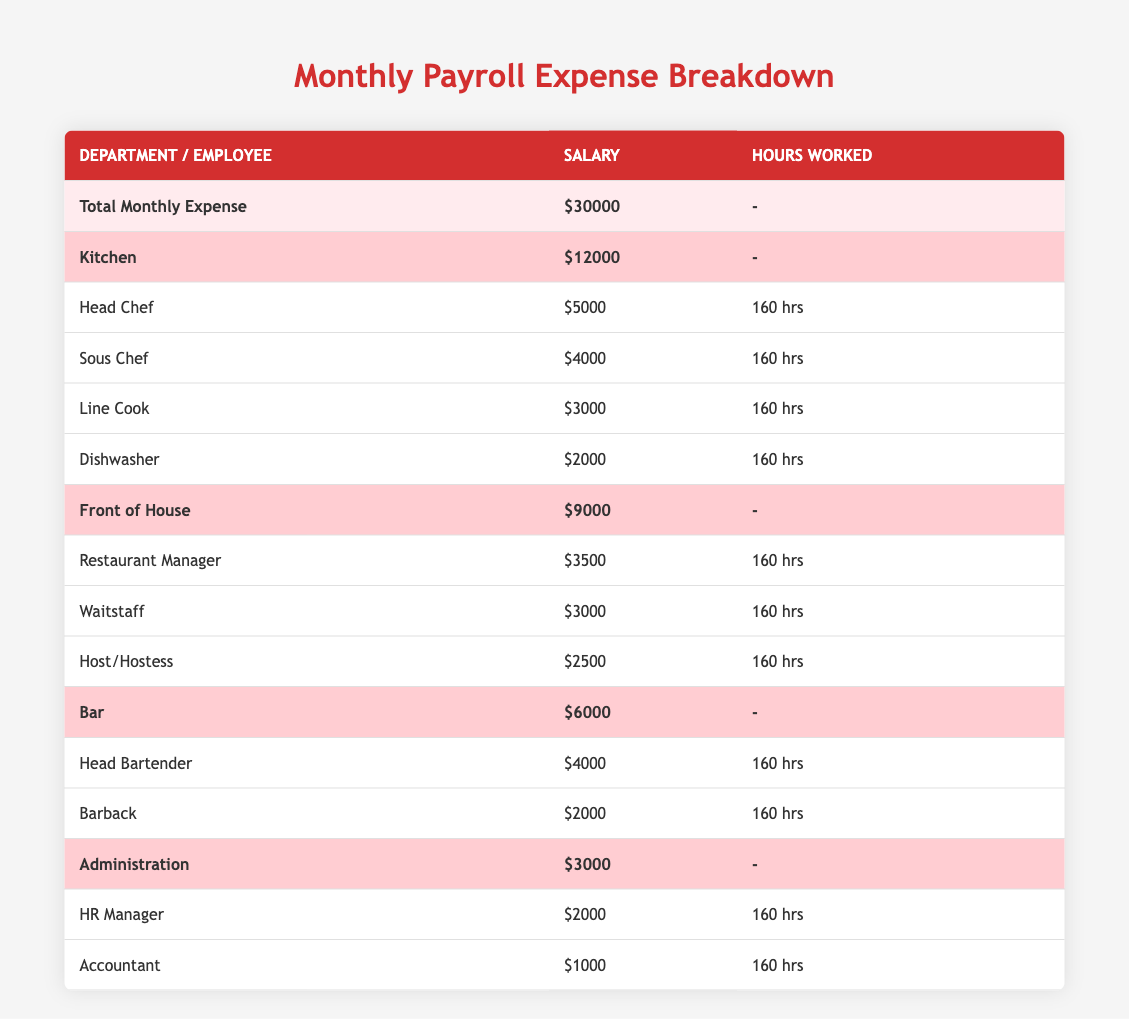What is the total monthly payroll expense? The total monthly payroll expense is provided in the first row of the table. It states that the total is 30000.
Answer: 30000 Which department has the highest payroll expense? In the departments listed, the Kitchen has the highest total expense of 12000, which is more than the expenses of Front of House (9000), Bar (6000), and Administration (3000).
Answer: Kitchen How much does the Sous Chef earn? The salary for the Sous Chef is listed directly under the Kitchen department, indicating a salary of 4000.
Answer: 4000 What is the combined payroll expense for Front of House and Bar departments? The Front of House has a total expense of 9000, and the Bar has 6000. Adding these two gives 9000 + 6000 = 15000.
Answer: 15000 Is the Accountant's salary greater than the Dishwasher's salary? The Accountant's salary is stated as 1000, while the Dishwasher's salary is 2000. Since 1000 is less than 2000, the statement is false.
Answer: No What is the average salary of employees in the Kitchen department? The total salary for the Kitchen department is the sum of the salaries of all employees (5000 + 4000 + 3000 + 2000 = 14000). There are 4 employees, thus the average salary is 14000 / 4 = 3500.
Answer: 3500 Which employee works the same number of hours as the Head Chef? The Head Chef works 160 hours. Looking at all employees in the table, each of them also works 160 hours (Sous Chef, Line Cook, Dishwasher, Restaurant Manager, Waitstaff, Host/Hostess, Head Bartender, Barback, HR Manager, and Accountant).
Answer: All employees What is the difference in total expense between the Kitchen and Administration departments? The Kitchen's total expense is 12000, while the Administration's total expense is 3000. The difference is calculated as 12000 - 3000 = 9000.
Answer: 9000 How much do all Bar employees earn combined? In the Bar department, the Head Bartender earns 4000, and the Barback earns 2000. Adding these salaries gives a total of 4000 + 2000 = 6000.
Answer: 6000 